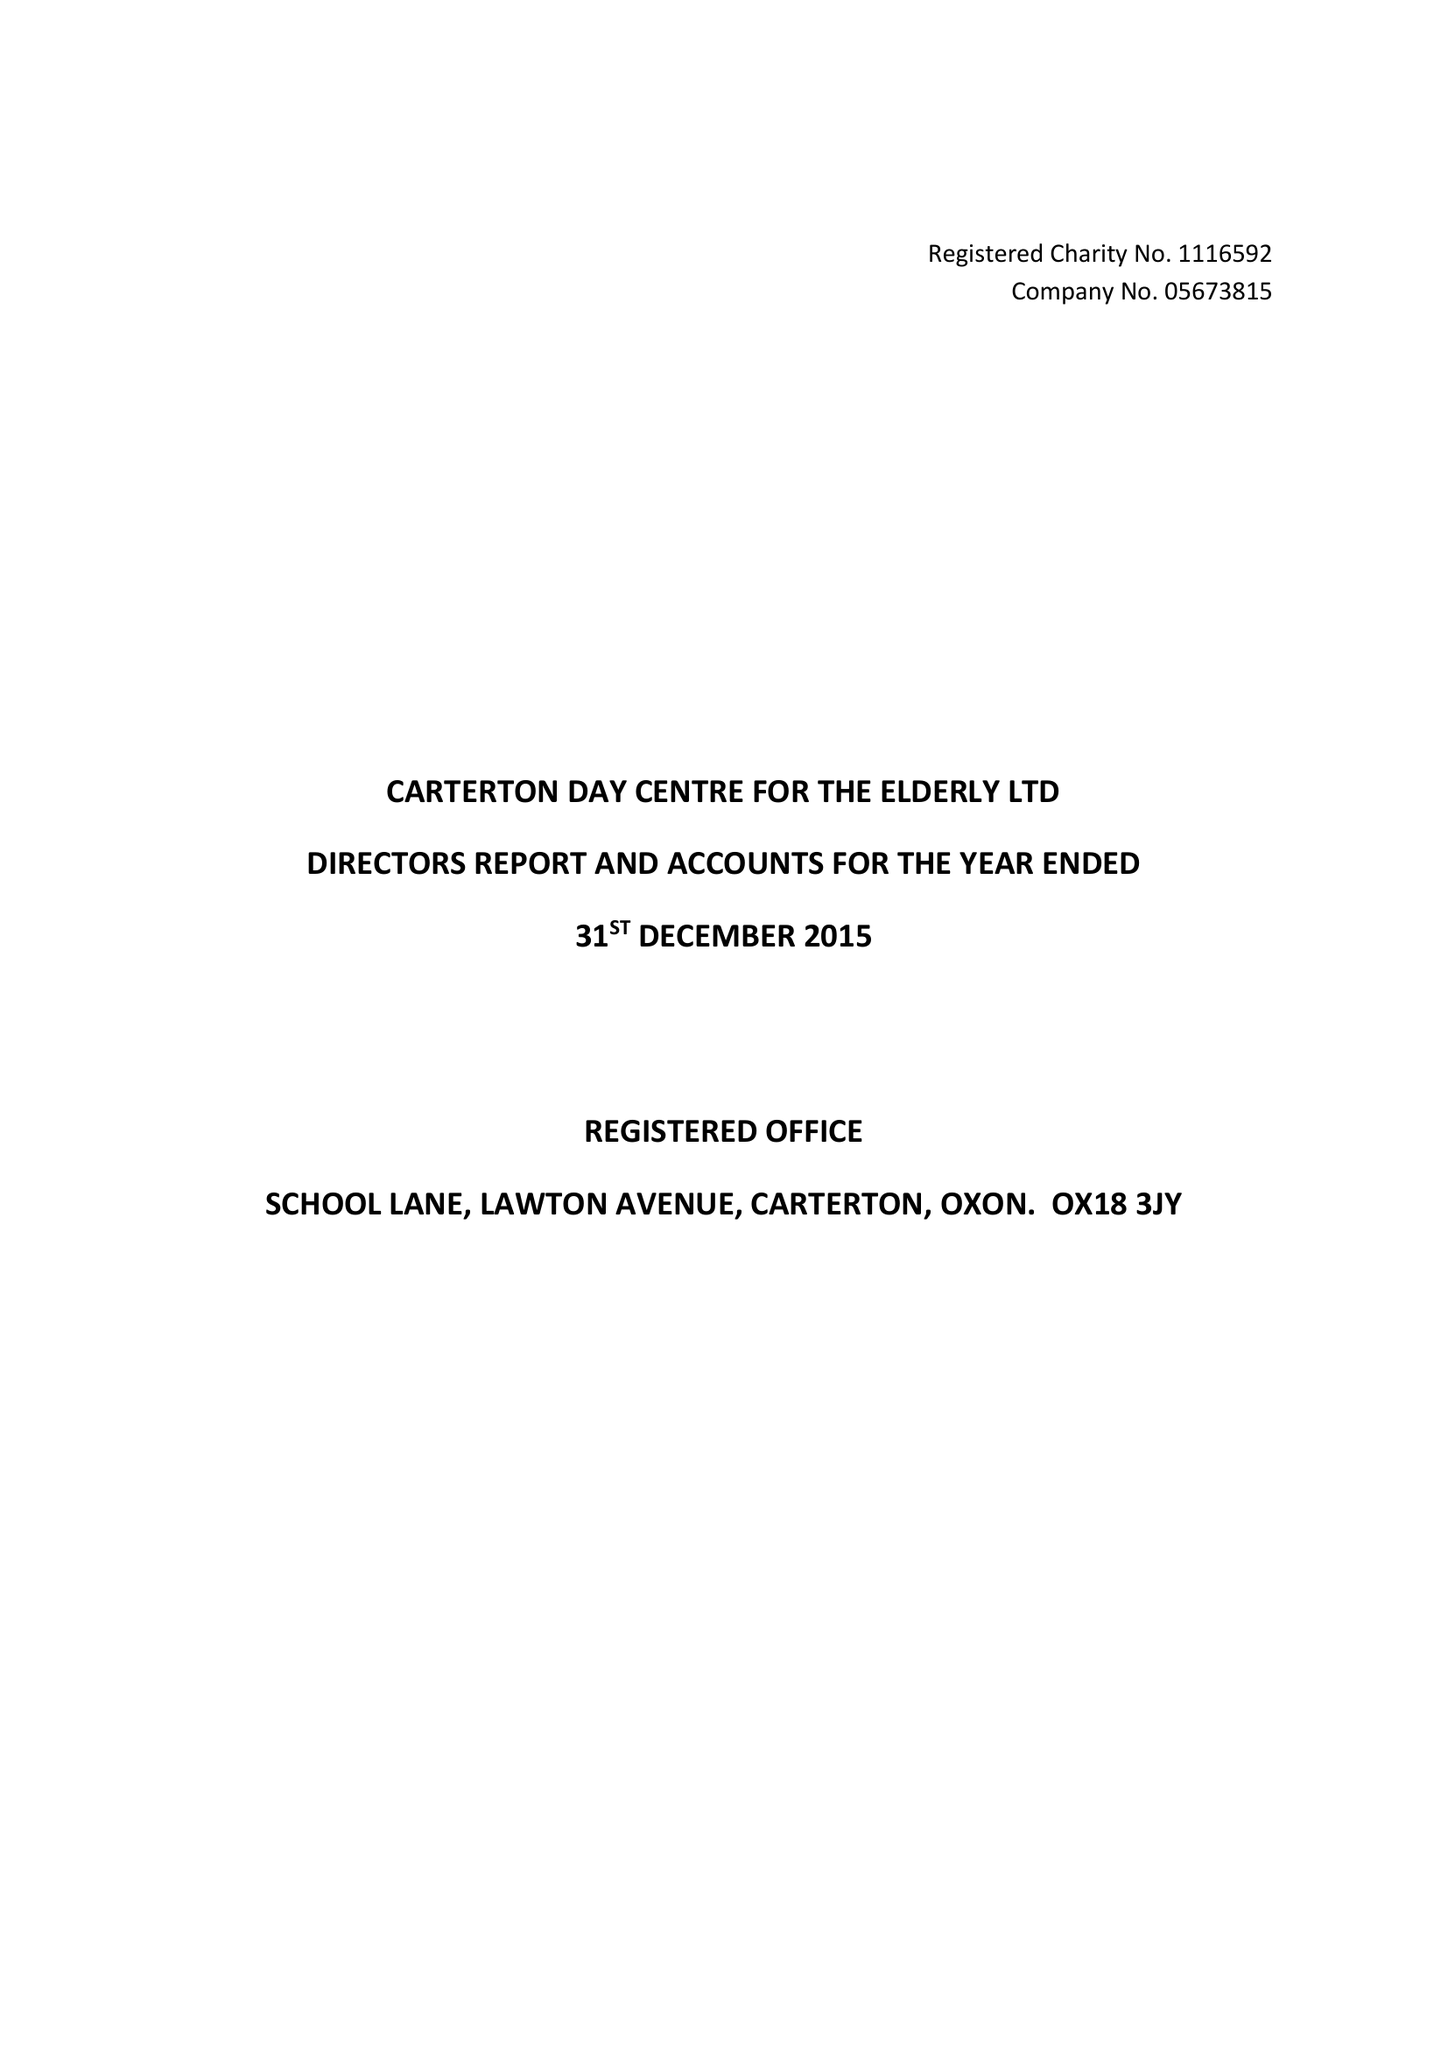What is the value for the charity_name?
Answer the question using a single word or phrase. Carterton Day Centre For The Elderly Ltd. 